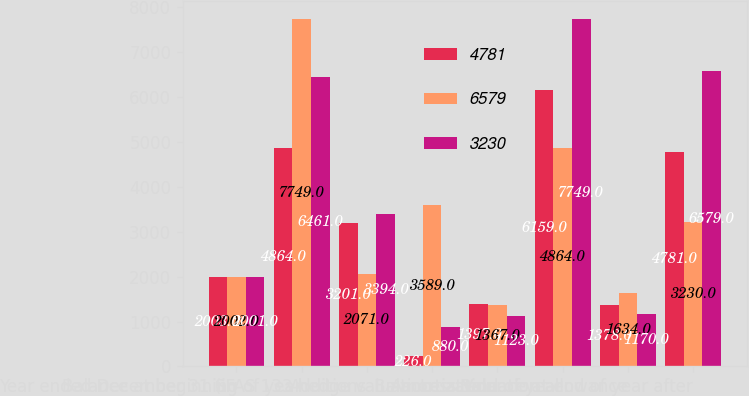Convert chart. <chart><loc_0><loc_0><loc_500><loc_500><stacked_bar_chart><ecel><fcel>Year ended December 31 (in<fcel>Balance at beginning of year<fcel>Additions<fcel>SFAS 133 hedge valuation<fcel>Amortization<fcel>Balance at end of year<fcel>Less Valuation allowance<fcel>Balance at end of year after<nl><fcel>4781<fcel>2003<fcel>4864<fcel>3201<fcel>226<fcel>1397<fcel>6159<fcel>1378<fcel>4781<nl><fcel>6579<fcel>2002<fcel>7749<fcel>2071<fcel>3589<fcel>1367<fcel>4864<fcel>1634<fcel>3230<nl><fcel>3230<fcel>2001<fcel>6461<fcel>3394<fcel>880<fcel>1123<fcel>7749<fcel>1170<fcel>6579<nl></chart> 